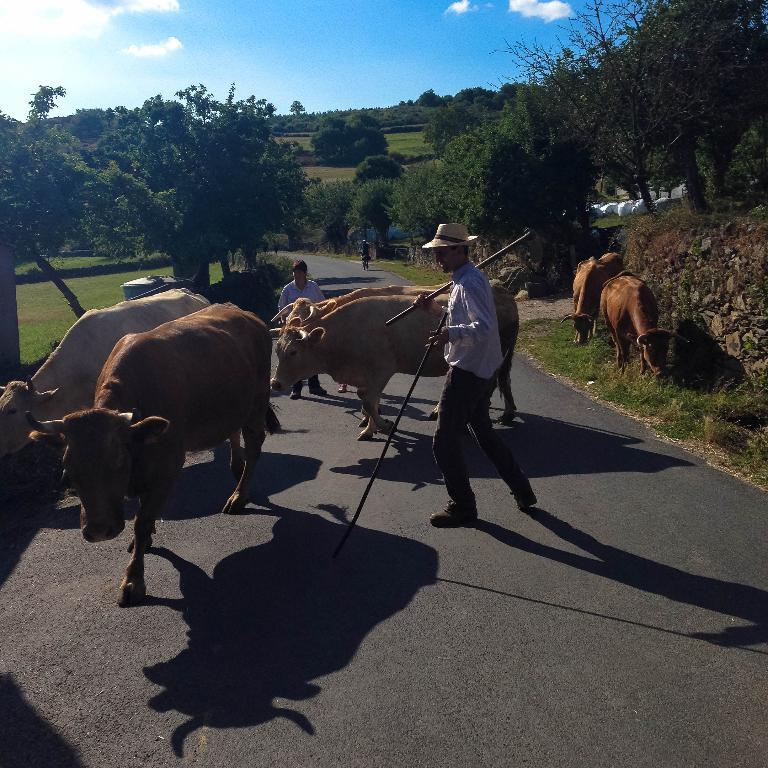What types of living beings are present in the image? There are animals and people in the image. What can be seen in the background of the image? There are trees in the image. What type of ground surface is visible in the image? There is grass in the image. How would you describe the weather based on the image? The sky is cloudy in the image, suggesting a potentially overcast or cloudy day. What is a person holding in the image? A person is holding sticks in the image. What type of cake is being served to the girl in the image? There is no girl or cake present in the image. What is the person using the iron for in the image? There is no iron present in the image. 